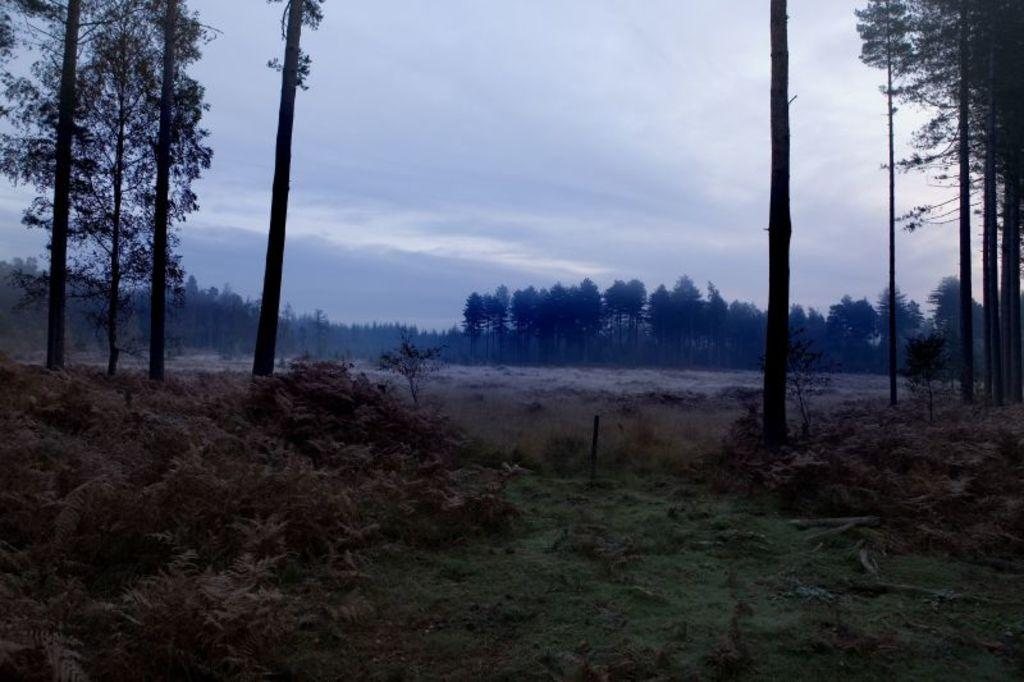What type of natural feature is present in the image? There is a river in the image. What other types of vegetation can be seen in the image? There are trees, plants, and bushes in the image. What part of the natural environment is visible in the image? The sky is visible in the image. What type of field can be seen in the image? There is no field present in the image. 